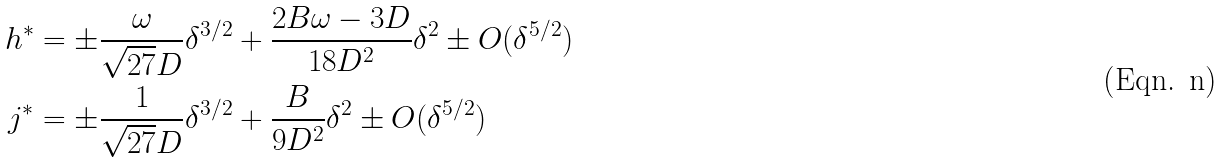<formula> <loc_0><loc_0><loc_500><loc_500>h ^ { * } & = \pm \frac { \omega } { \sqrt { 2 7 } D } \delta ^ { 3 / 2 } + \frac { 2 B \omega - 3 D } { 1 8 D ^ { 2 } } \delta ^ { 2 } \pm O ( \delta ^ { 5 / 2 } ) \\ j ^ { * } & = \pm \frac { 1 } { \sqrt { 2 7 } D } \delta ^ { 3 / 2 } + \frac { B } { 9 D ^ { 2 } } \delta ^ { 2 } \pm O ( \delta ^ { 5 / 2 } )</formula> 